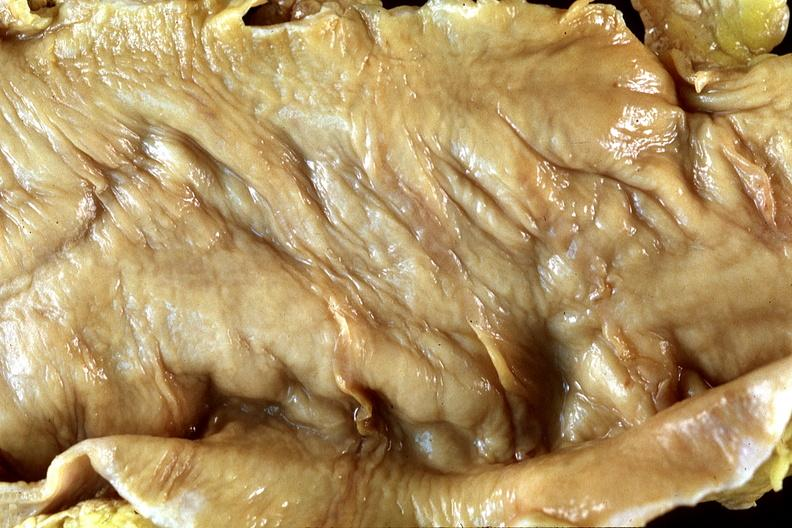s capillary present?
Answer the question using a single word or phrase. No 